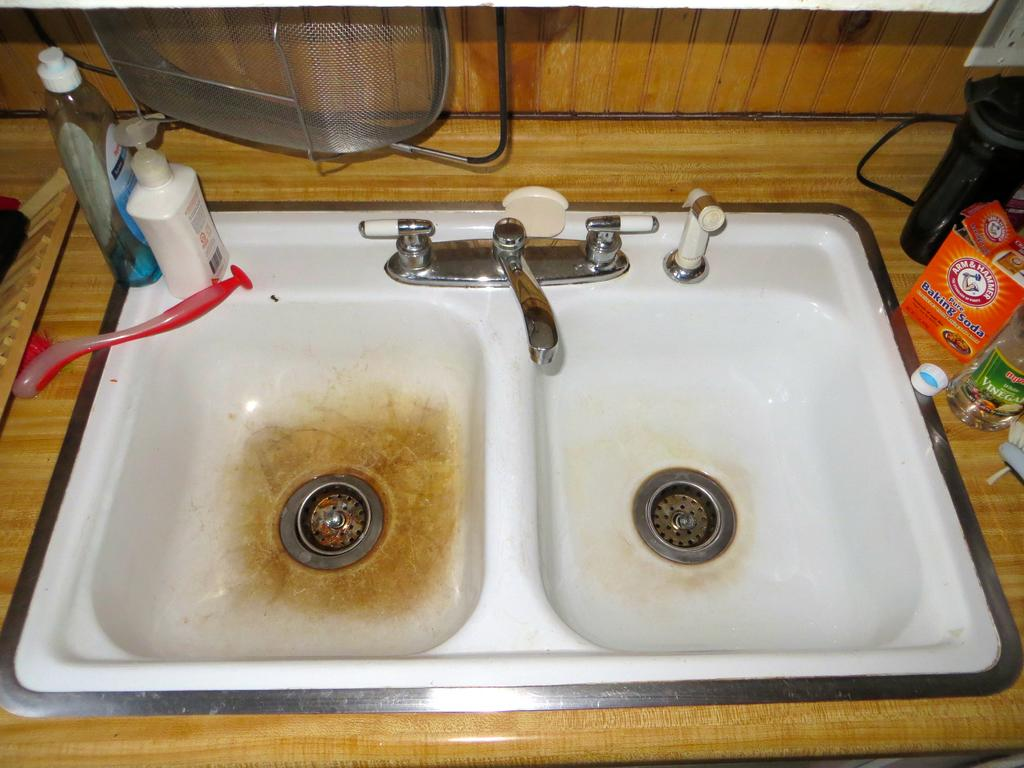What type of fixture is present in the image? There is a sink in the image. What is used to control the flow of water in the sink? There are taps in the image. What items can be seen that are commonly used in daily life? Daily essentials are present in the image. What device is used to control electrical appliances in the image? There is a switchboard in the image. What type of juice is being prepared in the image? There is no juice preparation visible in the image. What type of fuel is being used to power the appliances in the image? There is no fuel visible in the image, as the focus is on the sink, taps, daily essentials, and switchboard. 